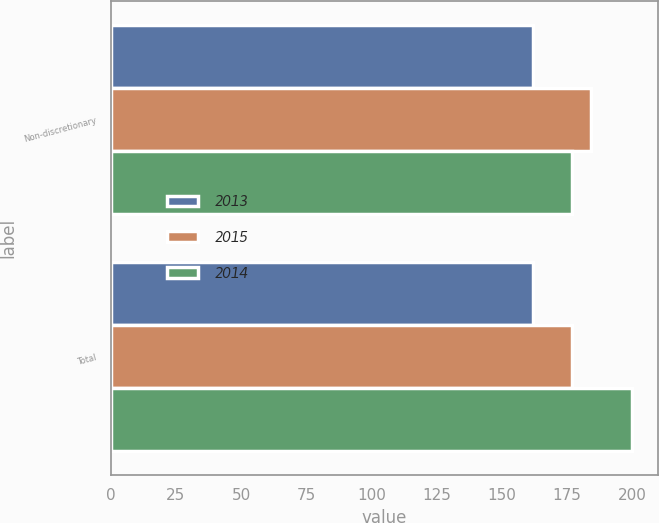<chart> <loc_0><loc_0><loc_500><loc_500><stacked_bar_chart><ecel><fcel>Non-discretionary<fcel>Total<nl><fcel>2013<fcel>162<fcel>162<nl><fcel>2015<fcel>184<fcel>177<nl><fcel>2014<fcel>177<fcel>200<nl></chart> 